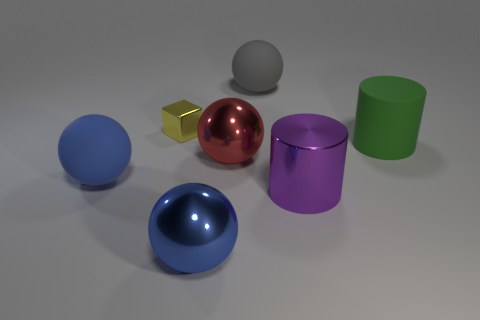There is a large sphere that is both on the right side of the big blue shiny sphere and in front of the tiny yellow cube; what material is it made of?
Make the answer very short. Metal. What color is the large shiny ball behind the big shiny sphere in front of the rubber object that is in front of the big matte cylinder?
Keep it short and to the point. Red. What number of brown things are either large shiny cylinders or big metal objects?
Offer a very short reply. 0. What number of other objects are the same size as the red thing?
Offer a very short reply. 5. What number of big blue matte spheres are there?
Provide a succinct answer. 1. Are there any other things that are the same shape as the yellow thing?
Ensure brevity in your answer.  No. Are the big blue thing behind the shiny cylinder and the blue sphere to the right of the yellow block made of the same material?
Make the answer very short. No. What is the material of the red ball?
Provide a succinct answer. Metal. How many balls have the same material as the gray object?
Give a very brief answer. 1. How many metallic objects are either cylinders or yellow blocks?
Your response must be concise. 2. 